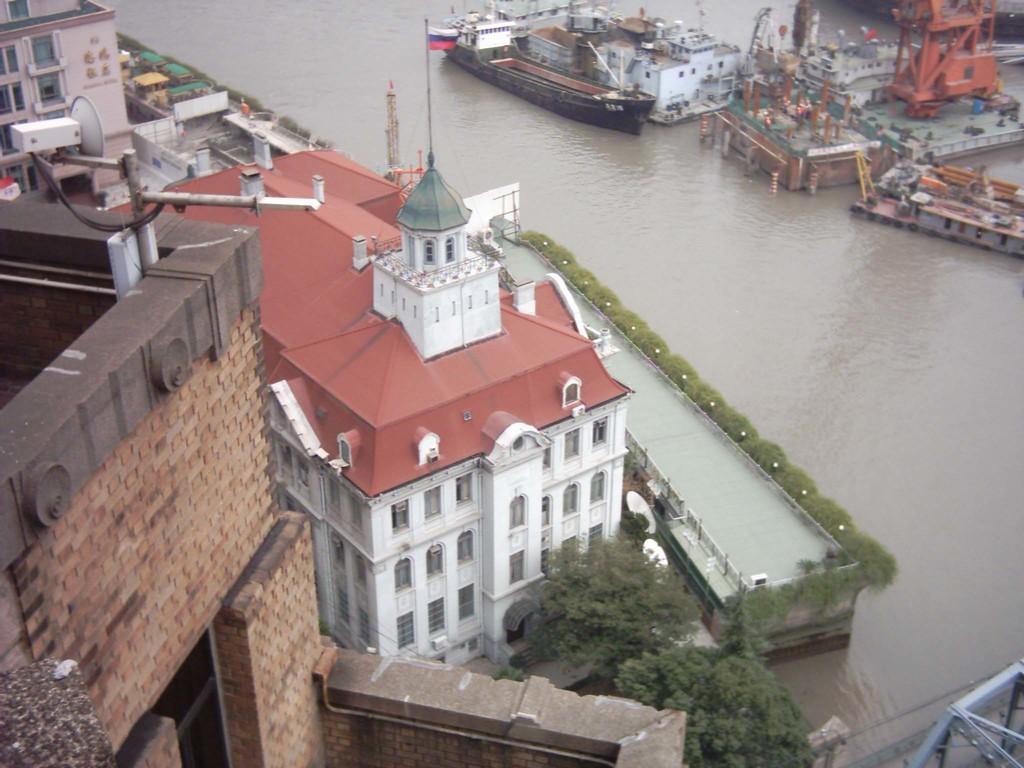Please provide a concise description of this image. This image is taken from the top. In the image we can see that there is water in the middle. In the water there are ships and boats. On the left side there are tall buildings. 